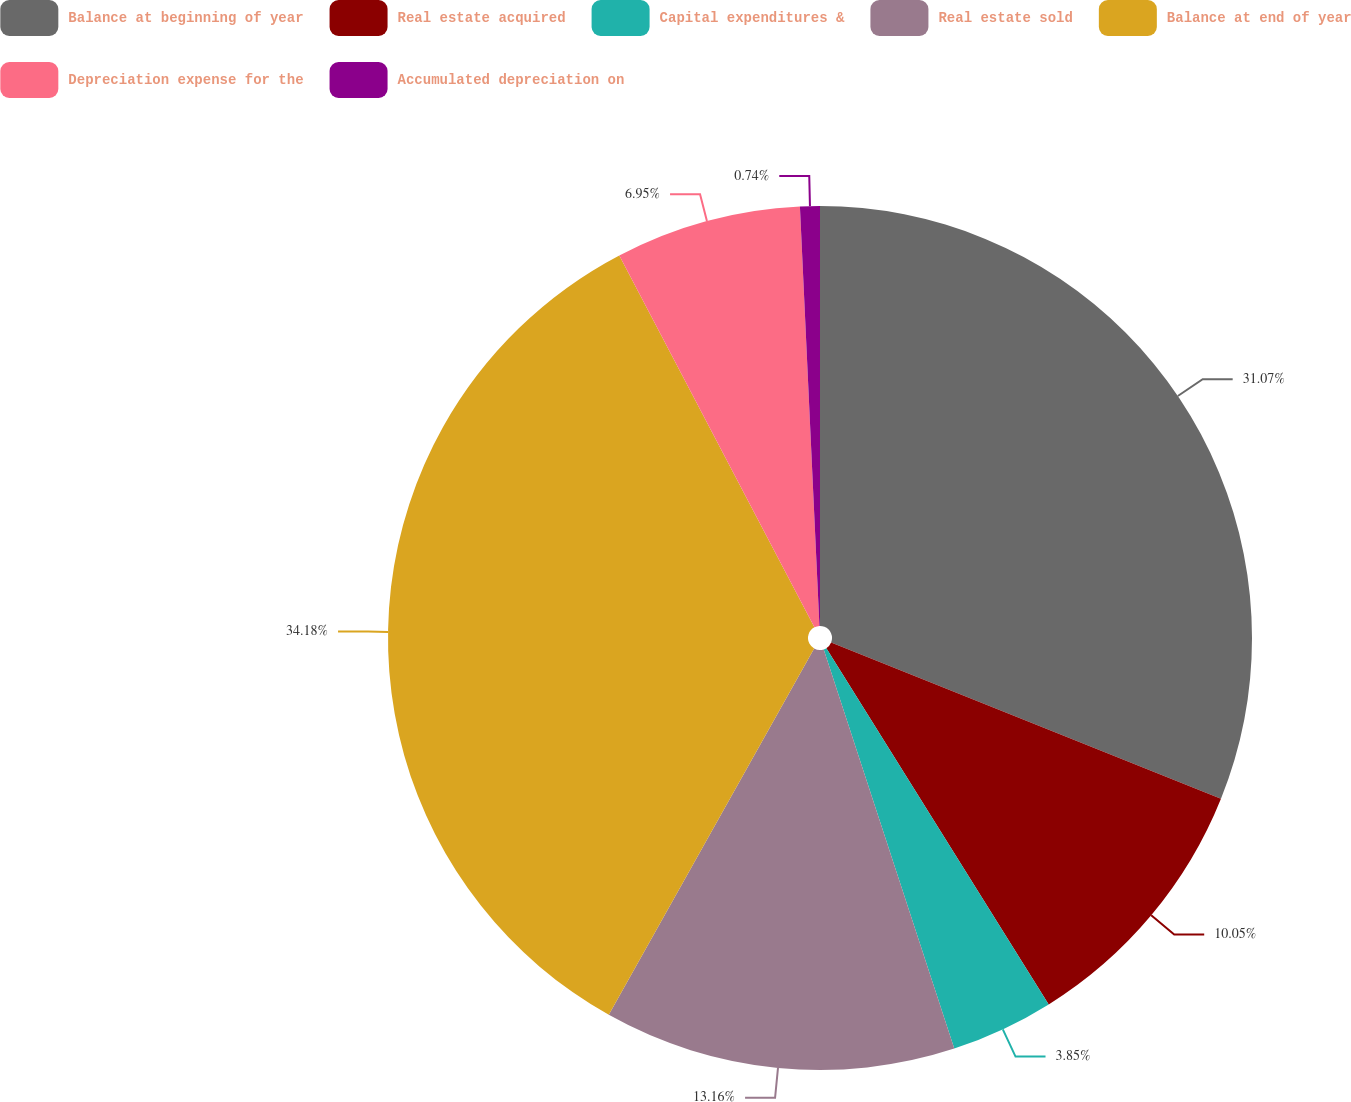<chart> <loc_0><loc_0><loc_500><loc_500><pie_chart><fcel>Balance at beginning of year<fcel>Real estate acquired<fcel>Capital expenditures &<fcel>Real estate sold<fcel>Balance at end of year<fcel>Depreciation expense for the<fcel>Accumulated depreciation on<nl><fcel>31.07%<fcel>10.05%<fcel>3.85%<fcel>13.16%<fcel>34.18%<fcel>6.95%<fcel>0.74%<nl></chart> 